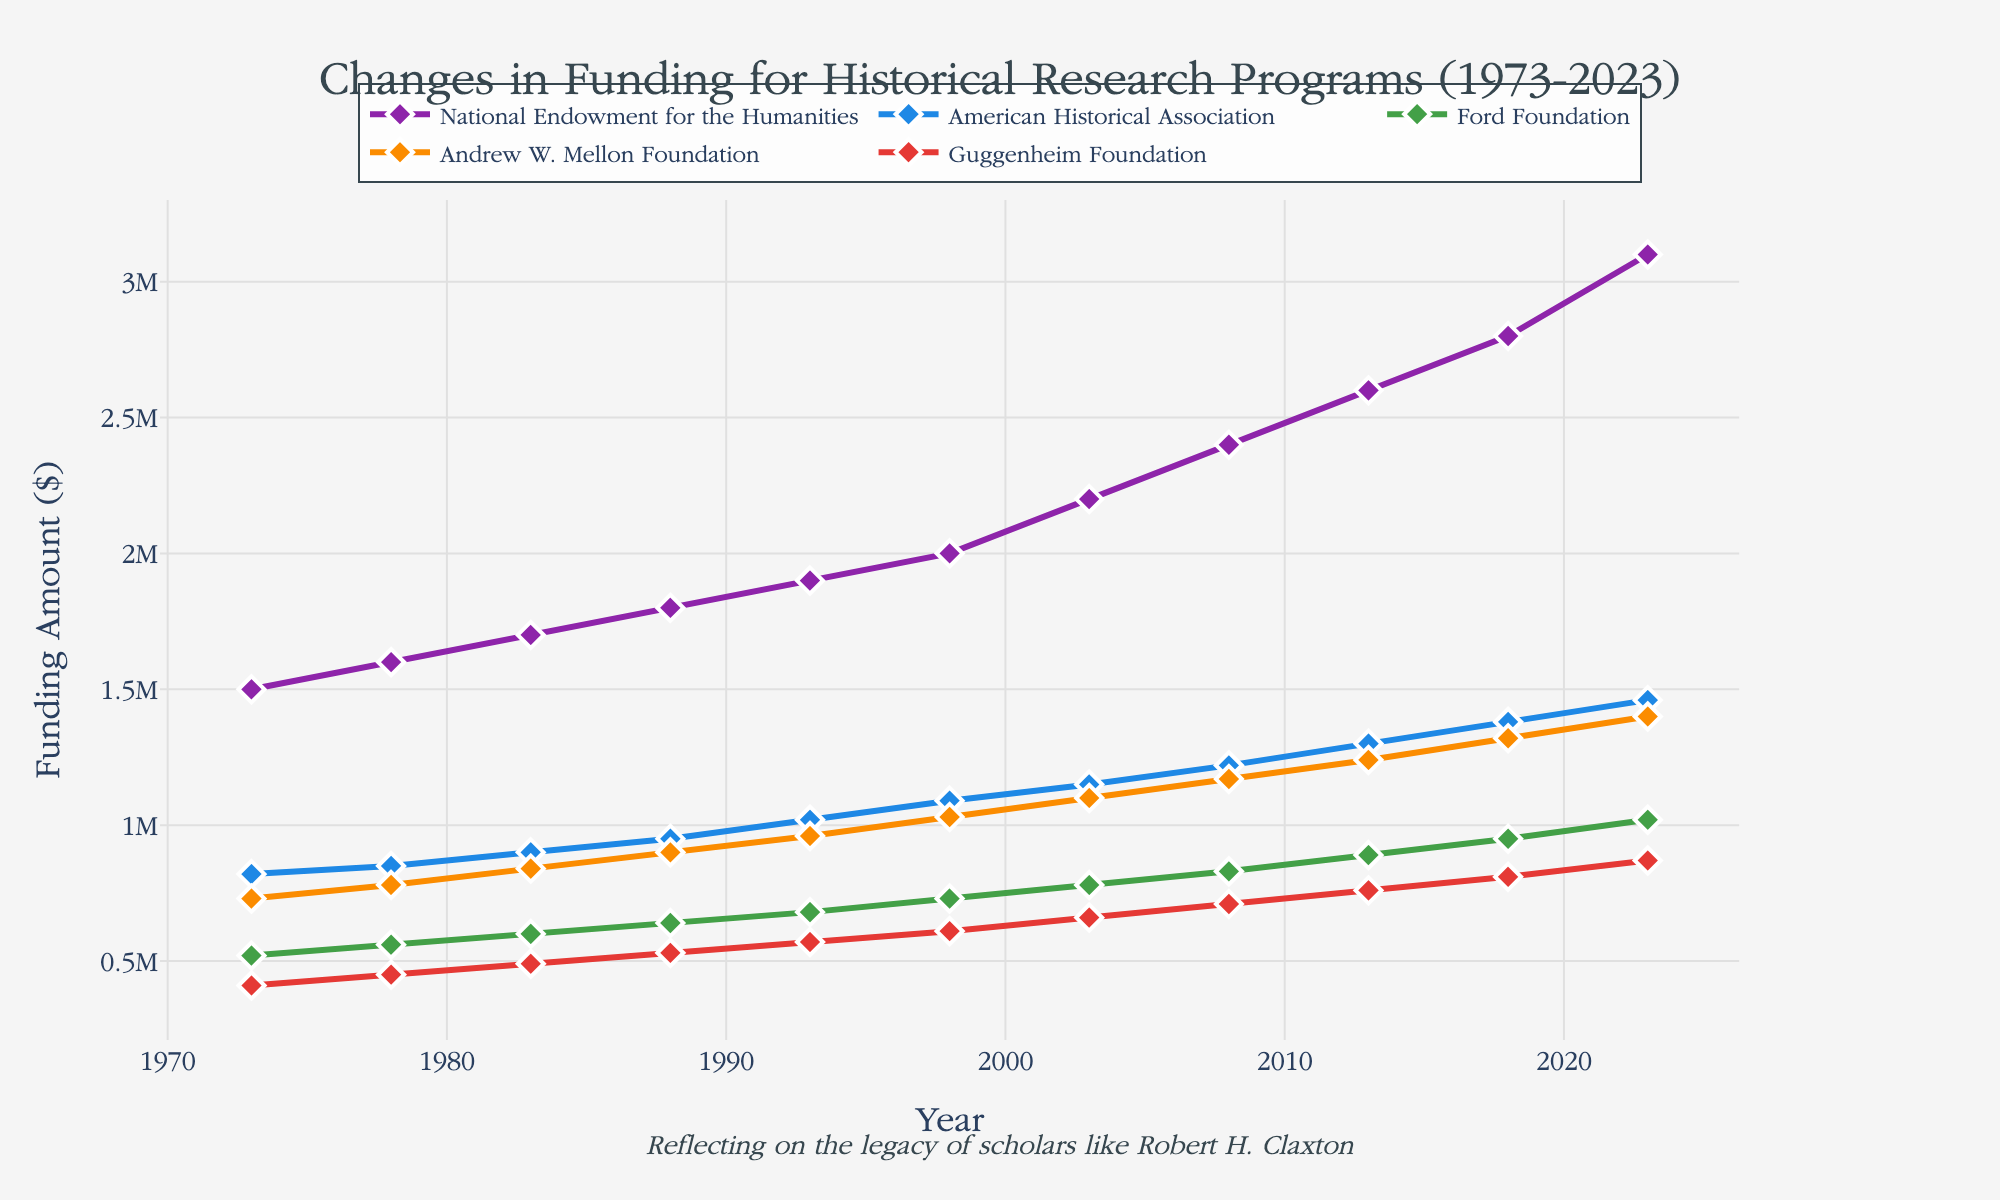what is the title of the figure? The title is usually prominently displayed at the top of the figure. In this case, the title can be found centered at the top of the plot.
Answer: Changes in Funding for Historical Research Programs (1973-2023) What are the years covered in the time series plot? To find the range of years covered, look at the x-axis, which represents time in the plot. The first and last tick labels will give the range.
Answer: 1973-2023 Which organization received the highest funding amount in 2023? Look at the data points for 2023 and compare the funding amounts for all organizations. The organization with the highest y-value (funding amount) in that year is the answer.
Answer: National Endowment for the Humanities Which organization saw the highest increase in funding between 1973 and 2023? Calculate the difference in funding amounts for each organization between 1973 and 2023, and compare these values to determine which organization had the largest increase.
Answer: National Endowment for the Humanities How did the funding for the Andrew W. Mellon Foundation change over the 50 years? Look at the points plotted for the Andrew W. Mellon Foundation to observe the trend in its funding from 1973 to 2023. The changes over time will be seen as increases or decreases along the line.
Answer: Increased What's the total funding reported by the American Historical Association over the years 1973, 1983, 1993, 2003, 2013, and 2023? Sum up the funding amounts of the American Historical Association for the specified years by reading the values directly off the plot.
Answer: 5,760,000 dollars What is the average funding amount for the Ford Foundation over the entire period? Add up all the funding amounts for the Ford Foundation from 1973 to 2023, then divide by the number of years to get the average.
Answer: $748,000 Which organization had the smallest funding increase over the 50 years? Calculate the difference in funding amounts between 1973 and 2023 for each organization. Compare these differences and identify the organization with the smallest increase.
Answer: Guggenheim Foundation How many data points are plotted for each organization? Count the number of points on any of the lines representing the organizations. Each point represents a data entry for a year. All organizations have the same number of data points since they are presented for the same years.
Answer: 11 